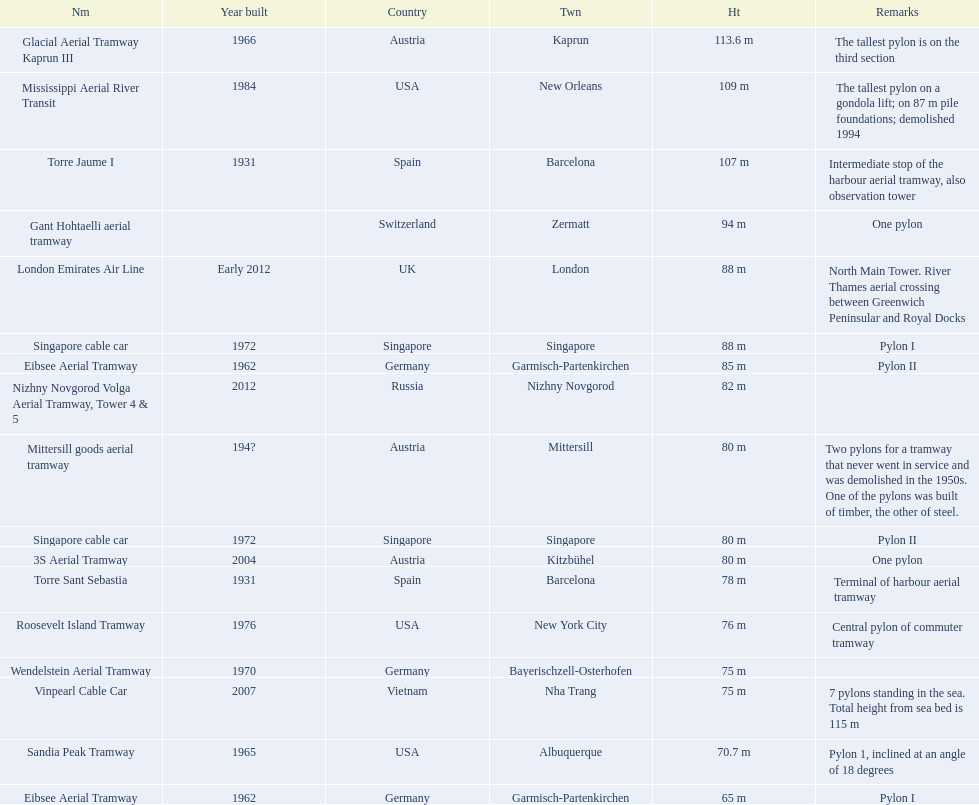How many aerial lift pylon's on the list are located in the usa? Mississippi Aerial River Transit, Roosevelt Island Tramway, Sandia Peak Tramway. Of the pylon's located in the usa how many were built after 1970? Mississippi Aerial River Transit, Roosevelt Island Tramway. Of the pylon's built after 1970 which is the tallest pylon on a gondola lift? Mississippi Aerial River Transit. How many meters is the tallest pylon on a gondola lift? 109 m. 